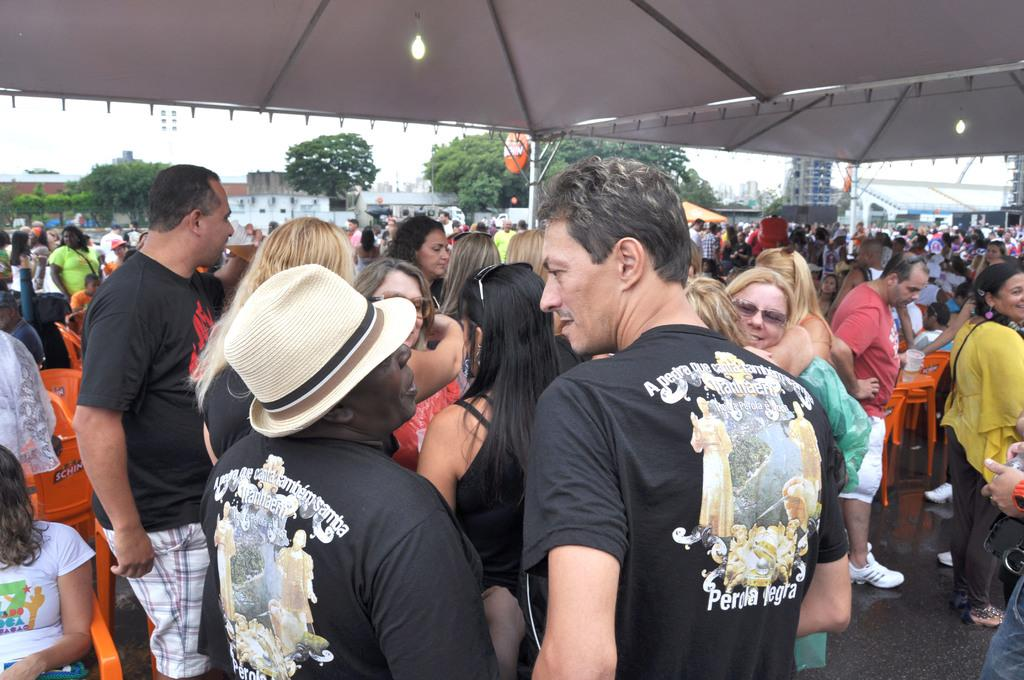What can be seen in the image that represents a large group of people? There is a crowd in the image. What type of furniture is present in the image? There are chairs in the image. What type of structures are visible in the image? There are buildings in the image. What type of vegetation is present in the image? There are trees in the image. What type of temporary shelter is present in the image? There are tents in the image. What type of illumination is present in the image? There are lights in the image. What can be seen in the background of the image? The sky is visible in the background of the image. What type of appliance is being used to design the buildings in the image? There is no mention of an appliance or design process in the image; it simply shows buildings, trees, chairs, tents, lights, a crowd, and the sky. 